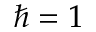<formula> <loc_0><loc_0><loc_500><loc_500>\hbar { = } 1</formula> 